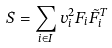<formula> <loc_0><loc_0><loc_500><loc_500>S = \sum _ { i \in I } v _ { i } ^ { 2 } F _ { i } \tilde { F } _ { i } ^ { T }</formula> 